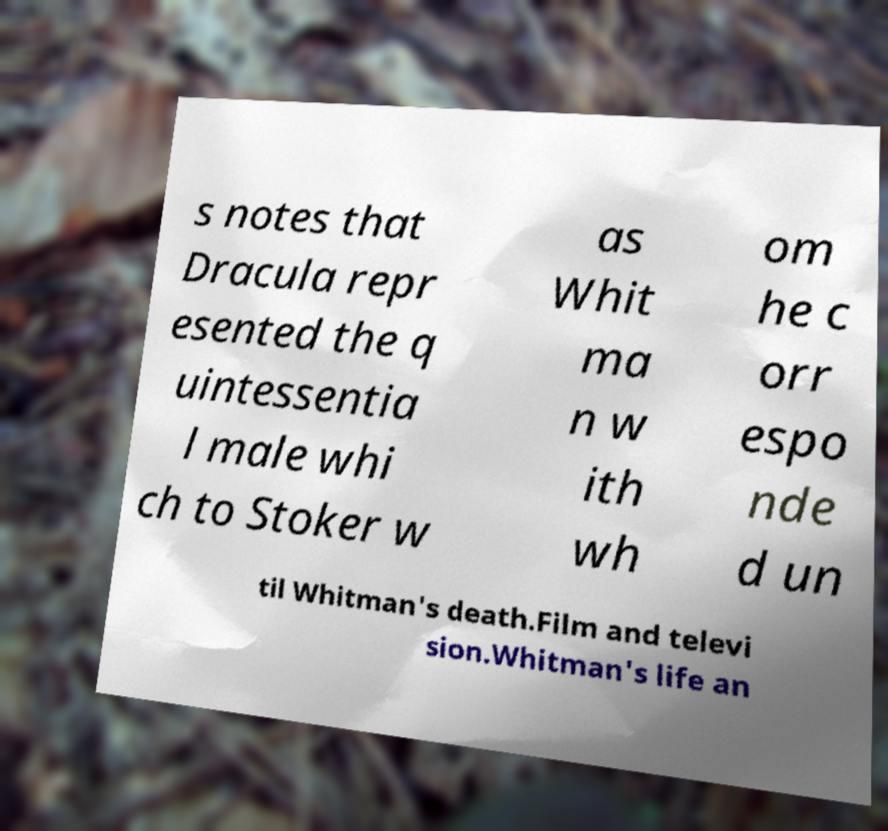There's text embedded in this image that I need extracted. Can you transcribe it verbatim? s notes that Dracula repr esented the q uintessentia l male whi ch to Stoker w as Whit ma n w ith wh om he c orr espo nde d un til Whitman's death.Film and televi sion.Whitman's life an 